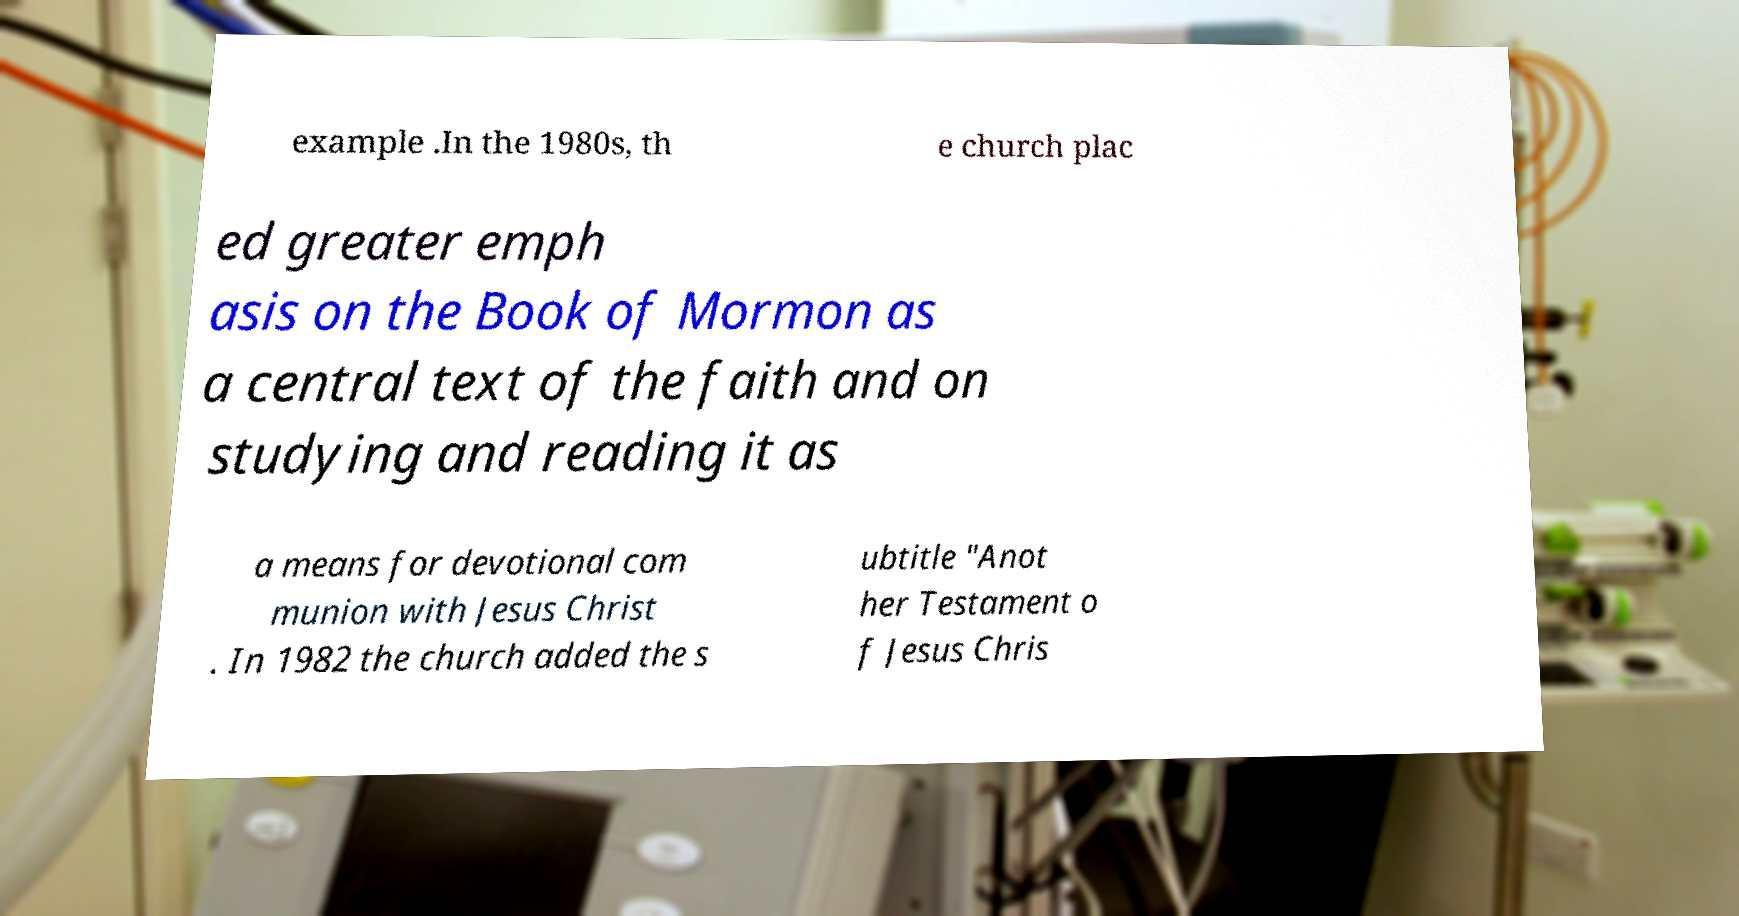I need the written content from this picture converted into text. Can you do that? example .In the 1980s, th e church plac ed greater emph asis on the Book of Mormon as a central text of the faith and on studying and reading it as a means for devotional com munion with Jesus Christ . In 1982 the church added the s ubtitle "Anot her Testament o f Jesus Chris 